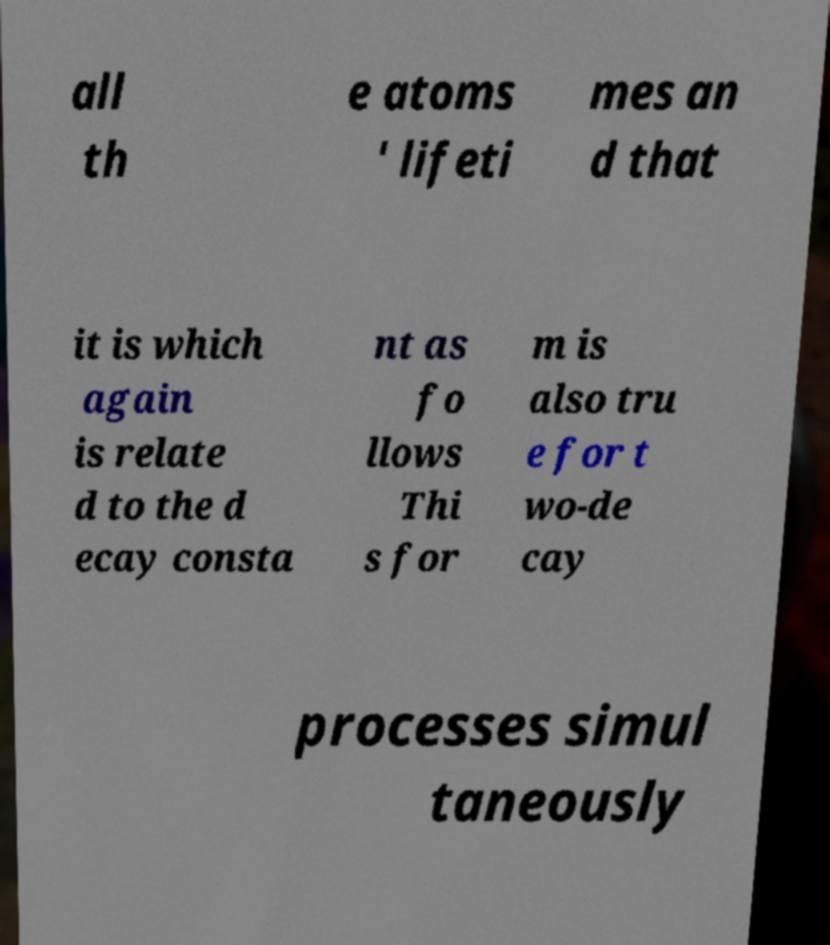There's text embedded in this image that I need extracted. Can you transcribe it verbatim? all th e atoms ' lifeti mes an d that it is which again is relate d to the d ecay consta nt as fo llows Thi s for m is also tru e for t wo-de cay processes simul taneously 